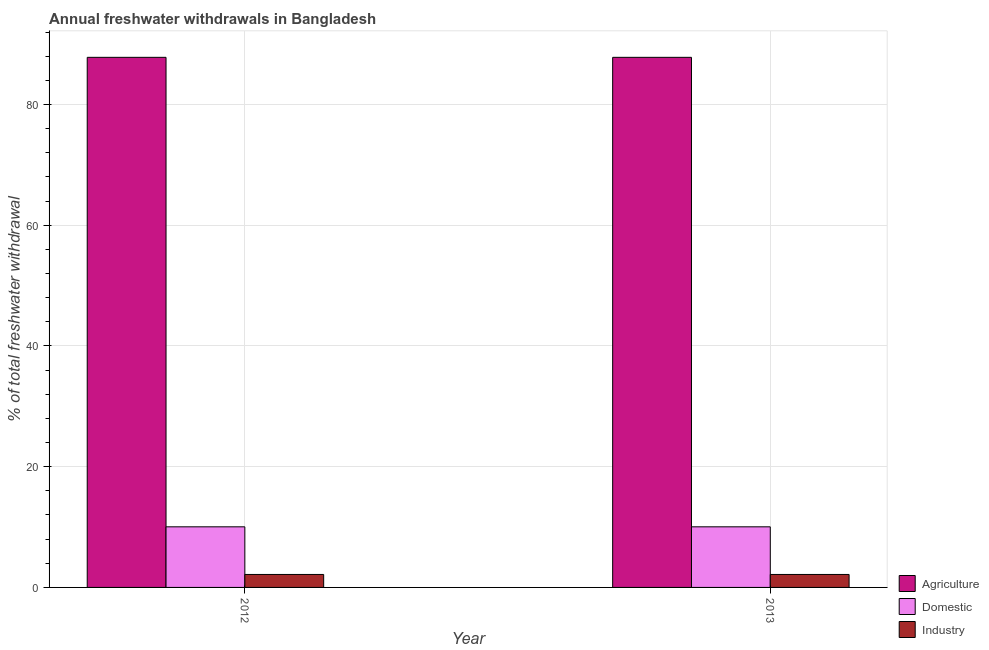How many bars are there on the 2nd tick from the left?
Ensure brevity in your answer.  3. What is the label of the 1st group of bars from the left?
Your response must be concise. 2012. What is the percentage of freshwater withdrawal for industry in 2012?
Give a very brief answer. 2.15. Across all years, what is the maximum percentage of freshwater withdrawal for domestic purposes?
Offer a terse response. 10.04. Across all years, what is the minimum percentage of freshwater withdrawal for agriculture?
Ensure brevity in your answer.  87.82. In which year was the percentage of freshwater withdrawal for industry maximum?
Keep it short and to the point. 2012. In which year was the percentage of freshwater withdrawal for industry minimum?
Provide a succinct answer. 2012. What is the total percentage of freshwater withdrawal for agriculture in the graph?
Your answer should be compact. 175.64. What is the difference between the percentage of freshwater withdrawal for domestic purposes in 2012 and that in 2013?
Provide a short and direct response. 0. What is the difference between the percentage of freshwater withdrawal for agriculture in 2013 and the percentage of freshwater withdrawal for industry in 2012?
Give a very brief answer. 0. What is the average percentage of freshwater withdrawal for domestic purposes per year?
Ensure brevity in your answer.  10.04. In how many years, is the percentage of freshwater withdrawal for domestic purposes greater than 40 %?
Your answer should be compact. 0. Is the percentage of freshwater withdrawal for domestic purposes in 2012 less than that in 2013?
Your answer should be compact. No. What does the 3rd bar from the left in 2013 represents?
Offer a terse response. Industry. What does the 1st bar from the right in 2013 represents?
Your answer should be compact. Industry. How many bars are there?
Offer a very short reply. 6. Are all the bars in the graph horizontal?
Your answer should be compact. No. What is the difference between two consecutive major ticks on the Y-axis?
Your answer should be very brief. 20. Are the values on the major ticks of Y-axis written in scientific E-notation?
Keep it short and to the point. No. Does the graph contain any zero values?
Make the answer very short. No. Does the graph contain grids?
Ensure brevity in your answer.  Yes. How are the legend labels stacked?
Give a very brief answer. Vertical. What is the title of the graph?
Your answer should be very brief. Annual freshwater withdrawals in Bangladesh. Does "New Zealand" appear as one of the legend labels in the graph?
Make the answer very short. No. What is the label or title of the Y-axis?
Keep it short and to the point. % of total freshwater withdrawal. What is the % of total freshwater withdrawal of Agriculture in 2012?
Keep it short and to the point. 87.82. What is the % of total freshwater withdrawal of Domestic in 2012?
Offer a terse response. 10.04. What is the % of total freshwater withdrawal in Industry in 2012?
Offer a very short reply. 2.15. What is the % of total freshwater withdrawal of Agriculture in 2013?
Your answer should be compact. 87.82. What is the % of total freshwater withdrawal in Domestic in 2013?
Provide a succinct answer. 10.04. What is the % of total freshwater withdrawal of Industry in 2013?
Keep it short and to the point. 2.15. Across all years, what is the maximum % of total freshwater withdrawal in Agriculture?
Ensure brevity in your answer.  87.82. Across all years, what is the maximum % of total freshwater withdrawal in Domestic?
Make the answer very short. 10.04. Across all years, what is the maximum % of total freshwater withdrawal of Industry?
Offer a very short reply. 2.15. Across all years, what is the minimum % of total freshwater withdrawal of Agriculture?
Offer a terse response. 87.82. Across all years, what is the minimum % of total freshwater withdrawal in Domestic?
Ensure brevity in your answer.  10.04. Across all years, what is the minimum % of total freshwater withdrawal of Industry?
Your response must be concise. 2.15. What is the total % of total freshwater withdrawal in Agriculture in the graph?
Give a very brief answer. 175.64. What is the total % of total freshwater withdrawal in Domestic in the graph?
Provide a succinct answer. 20.08. What is the total % of total freshwater withdrawal of Industry in the graph?
Provide a short and direct response. 4.29. What is the difference between the % of total freshwater withdrawal in Agriculture in 2012 and that in 2013?
Provide a succinct answer. 0. What is the difference between the % of total freshwater withdrawal in Domestic in 2012 and that in 2013?
Your answer should be very brief. 0. What is the difference between the % of total freshwater withdrawal of Agriculture in 2012 and the % of total freshwater withdrawal of Domestic in 2013?
Make the answer very short. 77.78. What is the difference between the % of total freshwater withdrawal of Agriculture in 2012 and the % of total freshwater withdrawal of Industry in 2013?
Your response must be concise. 85.67. What is the difference between the % of total freshwater withdrawal of Domestic in 2012 and the % of total freshwater withdrawal of Industry in 2013?
Offer a very short reply. 7.89. What is the average % of total freshwater withdrawal in Agriculture per year?
Provide a succinct answer. 87.82. What is the average % of total freshwater withdrawal of Domestic per year?
Make the answer very short. 10.04. What is the average % of total freshwater withdrawal in Industry per year?
Ensure brevity in your answer.  2.15. In the year 2012, what is the difference between the % of total freshwater withdrawal in Agriculture and % of total freshwater withdrawal in Domestic?
Offer a very short reply. 77.78. In the year 2012, what is the difference between the % of total freshwater withdrawal of Agriculture and % of total freshwater withdrawal of Industry?
Ensure brevity in your answer.  85.67. In the year 2012, what is the difference between the % of total freshwater withdrawal in Domestic and % of total freshwater withdrawal in Industry?
Provide a short and direct response. 7.89. In the year 2013, what is the difference between the % of total freshwater withdrawal of Agriculture and % of total freshwater withdrawal of Domestic?
Ensure brevity in your answer.  77.78. In the year 2013, what is the difference between the % of total freshwater withdrawal in Agriculture and % of total freshwater withdrawal in Industry?
Your answer should be very brief. 85.67. In the year 2013, what is the difference between the % of total freshwater withdrawal of Domestic and % of total freshwater withdrawal of Industry?
Make the answer very short. 7.89. What is the ratio of the % of total freshwater withdrawal of Agriculture in 2012 to that in 2013?
Offer a very short reply. 1. What is the ratio of the % of total freshwater withdrawal in Domestic in 2012 to that in 2013?
Ensure brevity in your answer.  1. What is the difference between the highest and the second highest % of total freshwater withdrawal in Agriculture?
Provide a succinct answer. 0. What is the difference between the highest and the lowest % of total freshwater withdrawal in Domestic?
Offer a terse response. 0. 